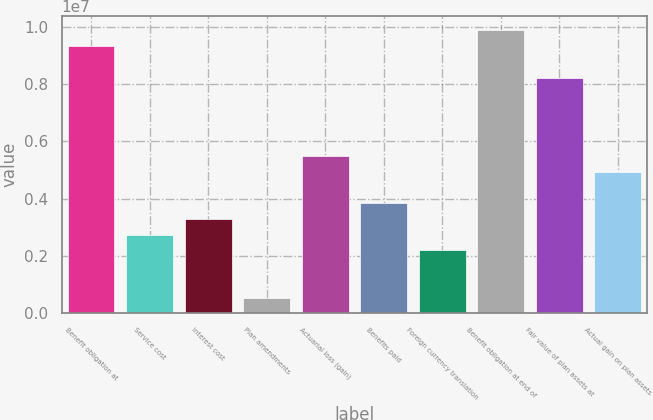<chart> <loc_0><loc_0><loc_500><loc_500><bar_chart><fcel>Benefit obligation at<fcel>Service cost<fcel>Interest cost<fcel>Plan amendments<fcel>Actuarial loss (gain)<fcel>Benefits paid<fcel>Foreign currency translation<fcel>Benefit obligation at end of<fcel>Fair value of plan assets at<fcel>Actual gain on plan assets<nl><fcel>9.32884e+06<fcel>2.74381e+06<fcel>3.29256e+06<fcel>548797<fcel>5.48757e+06<fcel>3.84132e+06<fcel>2.19506e+06<fcel>9.8776e+06<fcel>8.23134e+06<fcel>4.93882e+06<nl></chart> 